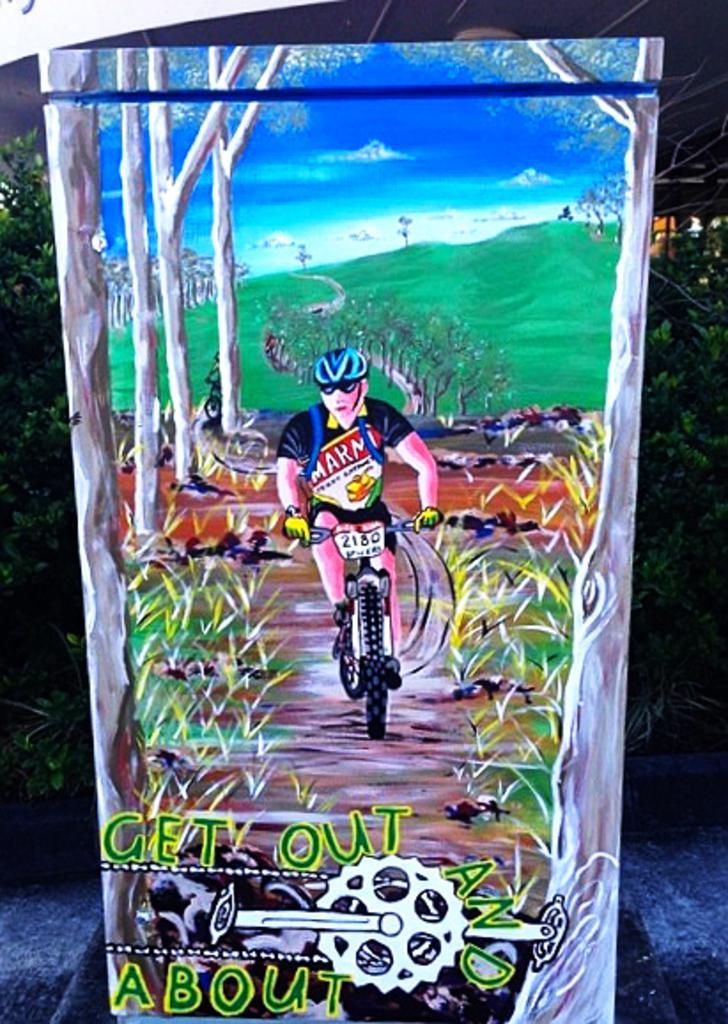Can you describe this image briefly? In this given picture, I can see a diagram which is drawn by someone else and there is a person, Who is riding a cycle behind the picture, I can see few trees and road. 